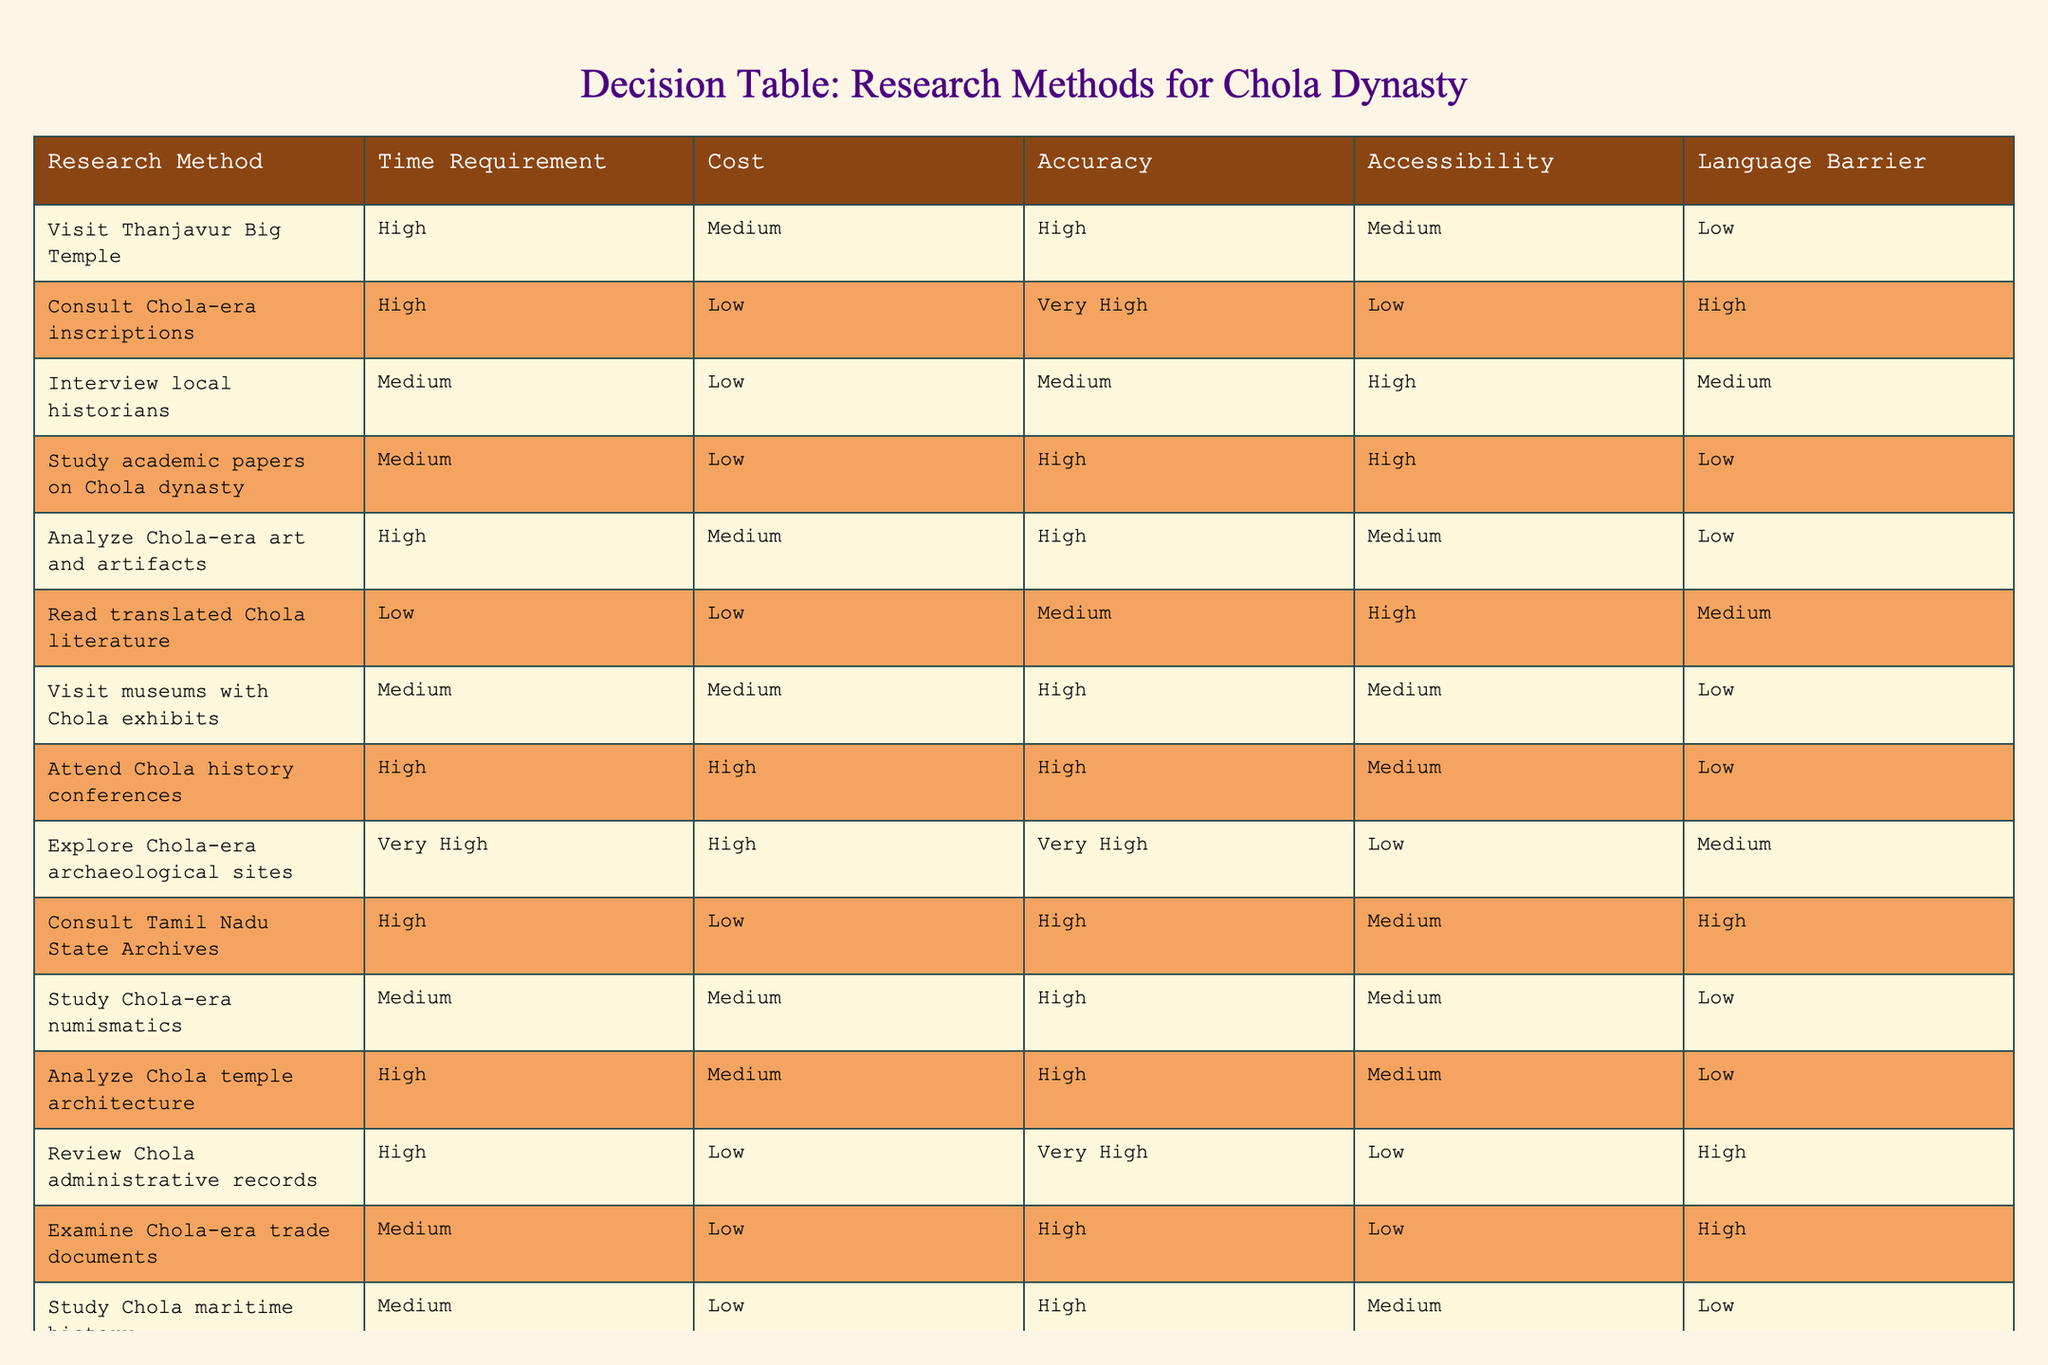What is the cost of interviewing local historians? The cost of interviewing local historians is listed under the "Cost" column for that research method, which shows "Low."
Answer: Low Which research method requires the most time? The research method that requires the most time is "Explore Chola-era archaeological sites," which is categorized as "Very High" in the "Time Requirement" column.
Answer: Explore Chola-era archaeological sites How many methods have high accuracy? There are four methods that have "High" accuracy: "Study academic papers on Chola dynasty," "Analyze Chola-era art and artifacts," "Study Chola-era numismatics," and "Examine Chola-era trade documents." Therefore, the total count is 4.
Answer: 4 Is attending Chola history conferences accessible? In the "Accessibility" column for "Attend Chola history conferences," it is listed as "Medium," indicating it is somewhat accessible, but not entirely.
Answer: No Which research method is not accessible and has low accessibility? The method "Consult Chola-era inscriptions" is categorized as "Low" under the "Accessibility" column, which means it is not accessible.
Answer: Consult Chola-era inscriptions What is the average time requirement for methods that have medium time requirements? The methods with medium time requirements are "Interview local historians," "Study academic papers on Chola dynasty," "Visit museums with Chola exhibits," "Study Chola-era numismatics," and "Study Chola maritime history." Their corresponding time requirements can be quantified as follows: "Medium" is the same as "2" (assuming High = 3, Medium = 2, Low = 1, Very High = 4). Summing these values gives 10 and averaging over 5 gives 2.
Answer: 2 Are there any methods that have both low cost and low accuracy? Upon analyzing the table, there are no methods listed with both "Low" cost and "Low" accuracy. Therefore, the answer is no.
Answer: No What is the maximum time requirement among the research methods? The maximum time requirement is found under "Explore Chola-era archaeological sites," which has a "Very High" time requirement. This categorization means it is the longest among all listed methods.
Answer: Explore Chola-era archaeological sites 